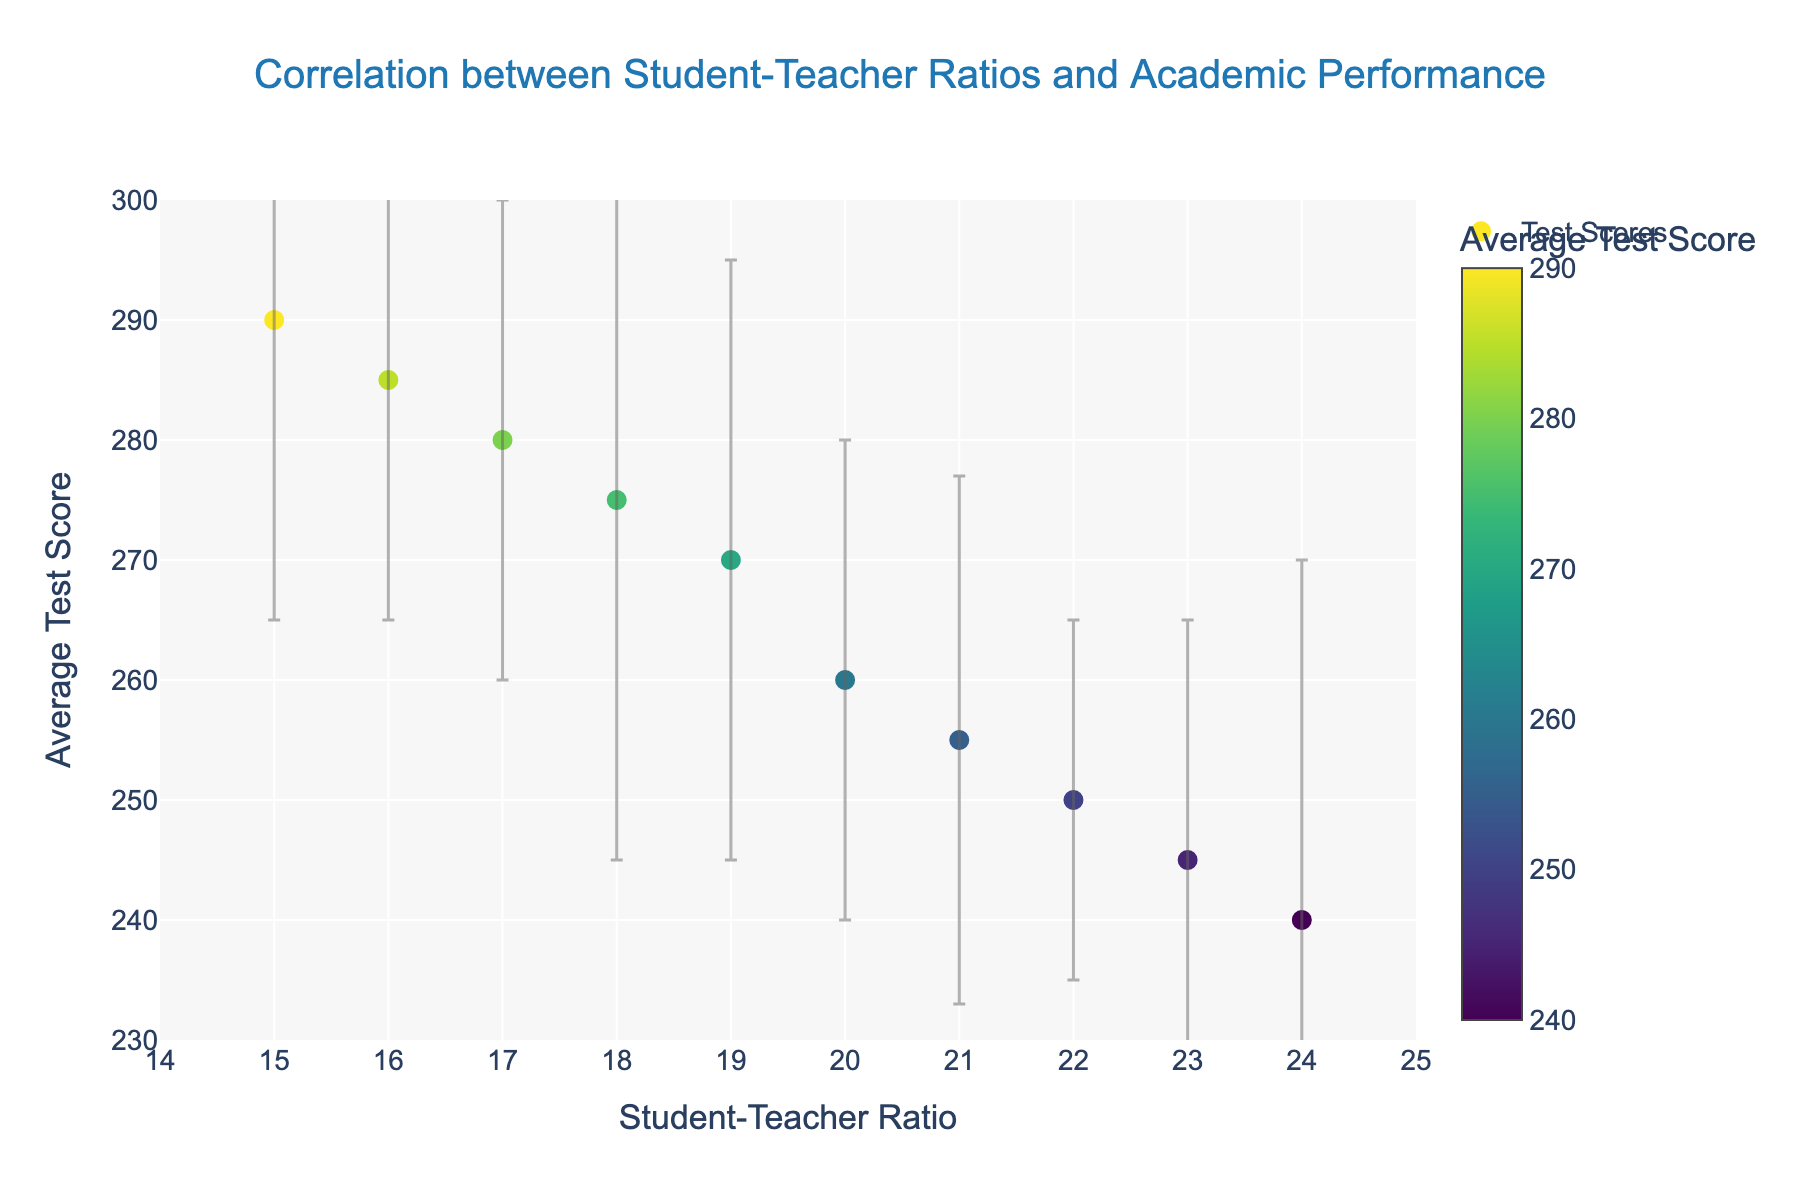How many districts are represented in the scatter plot? There are 10 distinct points (Springfield, Oakwood, Riverton, Brookside, Maplewood, Lakeside, Hillsborough, Westfield, Northridge, Greendale) on the plot, corresponding to 10 districts.
Answer: 10 What's the title of the scatter plot? The title is displayed at the top of the scatter plot.
Answer: Correlation between Student-Teacher Ratios and Academic Performance What is the range of Student-Teacher Ratios shown on the x-axis? The x-axis is labeled "Student-Teacher Ratio," and the range indicated is from 14 to 25.
Answer: 14 to 25 Which district has the highest average test score, and what is that score? Hovering over the points or viewing the coloring reveals that Springfield has the highest average test score of 290.
Answer: Springfield, 290 How does the error bar for Hillsborough compare to that of Maplewood? Hillsborough has a standard deviation of 30, and Maplewood has a standard deviation of 20, so the width of the error bar for Hillsborough is larger than that for Maplewood.
Answer: Hillsborough's is larger Is there a visible trend between the Student-Teacher Ratio and Average Test Score? By examining the scatter plot, it can be seen that as the Student-Teacher Ratio increases, the Average Test Score tends to decrease, showing a negative correlation.
Answer: Negative correlation What is the student-teacher ratio for Greendale, and what is its average test score? Greendale's point can be identified by hovering over it. Its student-teacher ratio is 23, and its average test score is 245.
Answer: 23, 245 Which district shows the greatest variability in average test score, and what is its standard deviation? The size of the error bars indicates variability. Hillsborough has the largest error bar, with a standard deviation of 30.
Answer: Hillsborough, 30 Compare the Student-Teacher Ratios and Average Test Scores of Westfield and Oakwood. Westfield has a Student-Teacher Ratio of 17 and an Average Test Score of 280. Oakwood has a Student-Teacher Ratio of 18 and an Average Test Score of 275.
Answer: Westfield: 17, 280; Oakwood: 18, 275 What's the median Student-Teacher Ratio among the districts? The Student-Teacher Ratios are: 15, 16, 17, 18, 19, 20, 21, 22, 23, 24. The median of this sorted list (10 values) is the average of the 5th and 6th values, so (19 + 20) / 2 = 19.5.
Answer: 19.5 